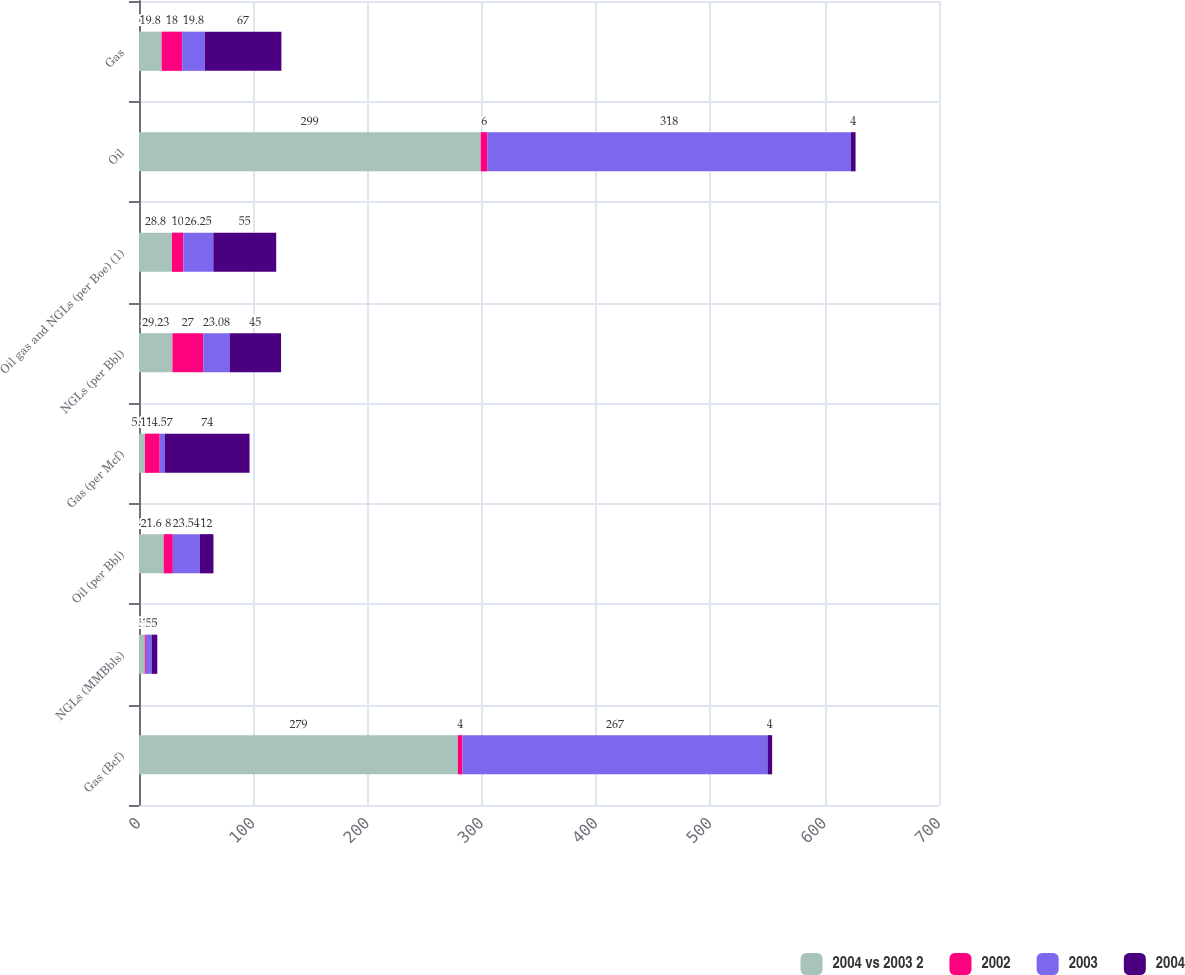Convert chart. <chart><loc_0><loc_0><loc_500><loc_500><stacked_bar_chart><ecel><fcel>Gas (Bcf)<fcel>NGLs (MMBbls)<fcel>Oil (per Bbl)<fcel>Gas (per Mcf)<fcel>NGLs (per Bbl)<fcel>Oil gas and NGLs (per Boe) (1)<fcel>Oil<fcel>Gas<nl><fcel>2004 vs 2003 2<fcel>279<fcel>5<fcel>21.6<fcel>5.15<fcel>29.23<fcel>28.8<fcel>299<fcel>19.8<nl><fcel>2002<fcel>4<fcel>1<fcel>8<fcel>13<fcel>27<fcel>10<fcel>6<fcel>18<nl><fcel>2003<fcel>267<fcel>5<fcel>23.54<fcel>4.57<fcel>23.08<fcel>26.25<fcel>318<fcel>19.8<nl><fcel>2004<fcel>4<fcel>5<fcel>12<fcel>74<fcel>45<fcel>55<fcel>4<fcel>67<nl></chart> 